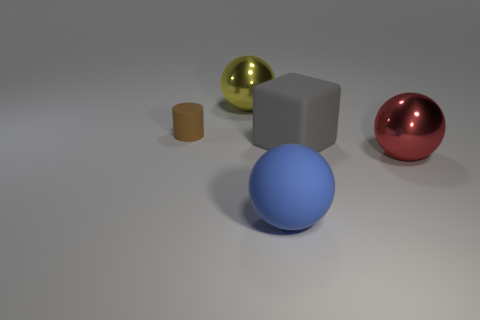What number of balls are rubber things or big red shiny things?
Your answer should be compact. 2. What color is the large metallic sphere in front of the metallic sphere that is on the left side of the red thing?
Make the answer very short. Red. Are there fewer large blue spheres right of the gray matte cube than small cylinders that are to the left of the large yellow metallic ball?
Your answer should be compact. Yes. There is a blue rubber ball; is it the same size as the matte thing behind the large gray object?
Make the answer very short. No. What shape is the thing that is right of the big matte sphere and behind the large red sphere?
Offer a terse response. Cube. What is the size of the red sphere that is the same material as the yellow object?
Your answer should be very brief. Large. How many brown cylinders are to the left of the shiny ball in front of the tiny matte object?
Offer a very short reply. 1. Do the ball to the left of the large blue matte thing and the big red thing have the same material?
Offer a very short reply. Yes. What is the size of the rubber object on the left side of the yellow shiny object behind the gray rubber object?
Make the answer very short. Small. What size is the object that is on the left side of the thing behind the matte object to the left of the yellow thing?
Keep it short and to the point. Small. 